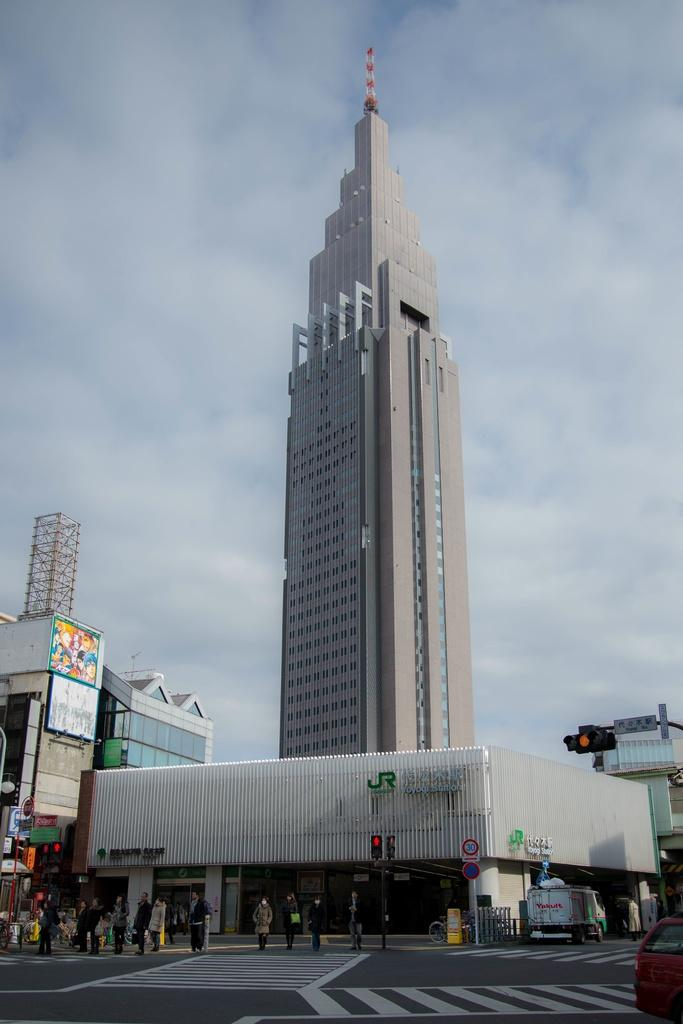What is happening in the image? There is a group of people standing in the image. What else can be seen in the image besides the people? There are vehicles on the road, buildings, poles, boards, and lights in the image. What is visible in the background of the image? The sky is visible in the background of the image. What type of bomb can be seen in the image? There is no bomb present in the image. How does the tank affect the scene in the image? There is no tank present in the image. 